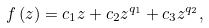Convert formula to latex. <formula><loc_0><loc_0><loc_500><loc_500>f \left ( z \right ) = c _ { 1 } z + c _ { 2 } z ^ { q _ { 1 } } + c _ { 3 } z ^ { q _ { 2 } } ,</formula> 